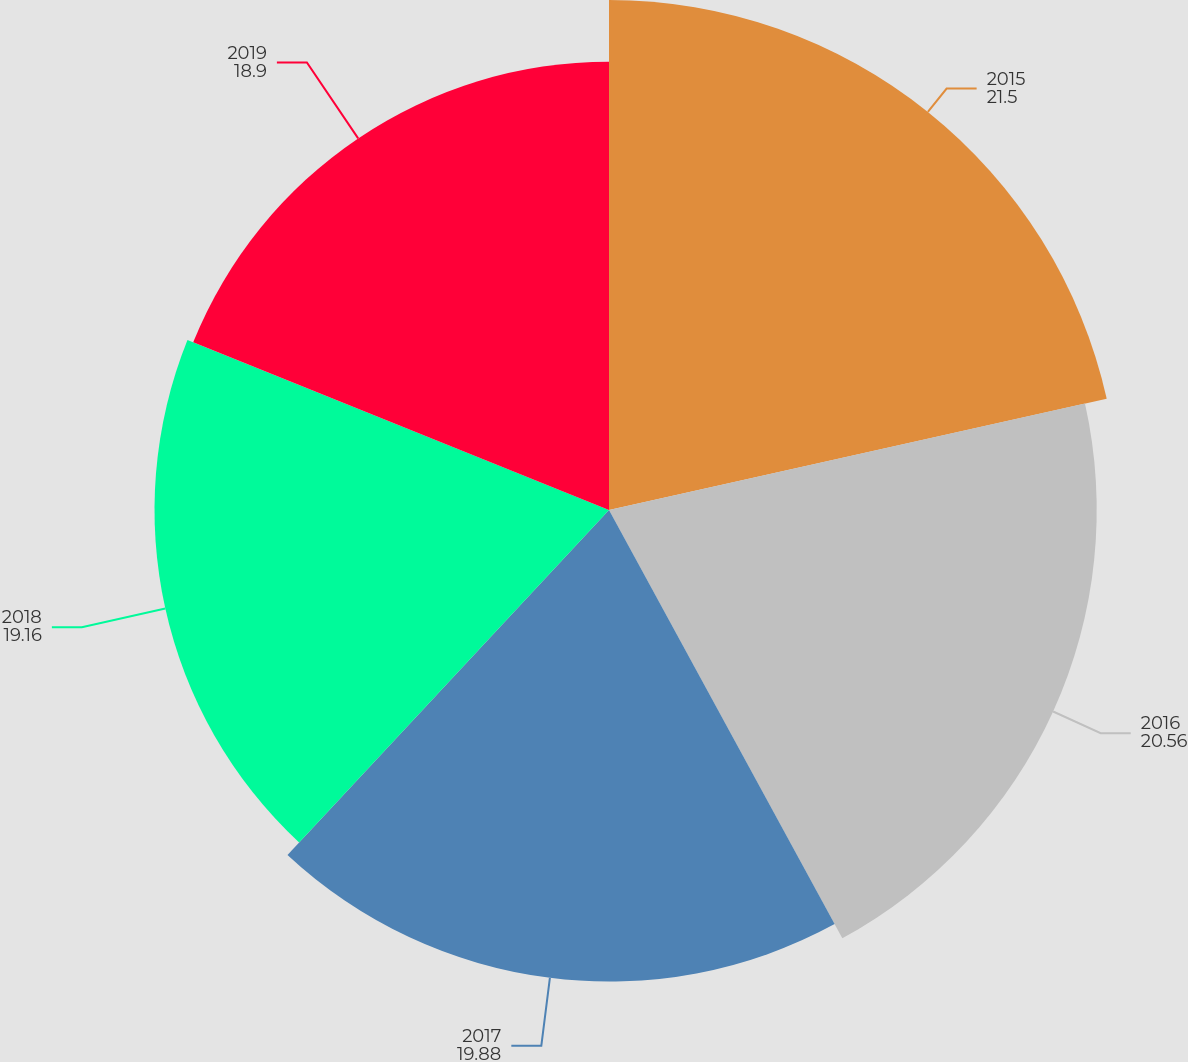Convert chart. <chart><loc_0><loc_0><loc_500><loc_500><pie_chart><fcel>2015<fcel>2016<fcel>2017<fcel>2018<fcel>2019<nl><fcel>21.5%<fcel>20.56%<fcel>19.88%<fcel>19.16%<fcel>18.9%<nl></chart> 